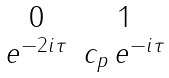Convert formula to latex. <formula><loc_0><loc_0><loc_500><loc_500>\begin{matrix} 0 & 1 \\ e ^ { - 2 i \tau } & c _ { p } \, e ^ { - i \tau } \end{matrix}</formula> 